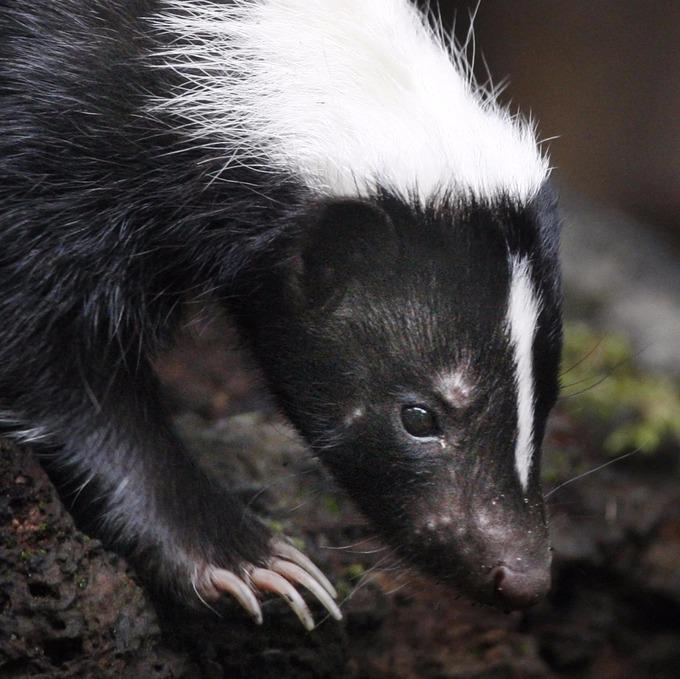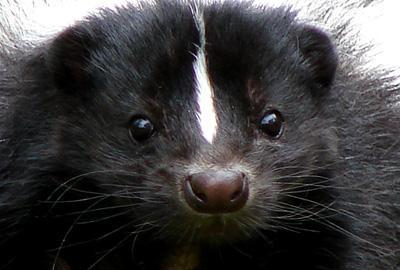The first image is the image on the left, the second image is the image on the right. Analyze the images presented: Is the assertion "The left image features a skunk with a thin white stripe down its rightward-turned head, and the right image features a forward-facing skunk that does not have white fur covering the top of its head." valid? Answer yes or no. Yes. 